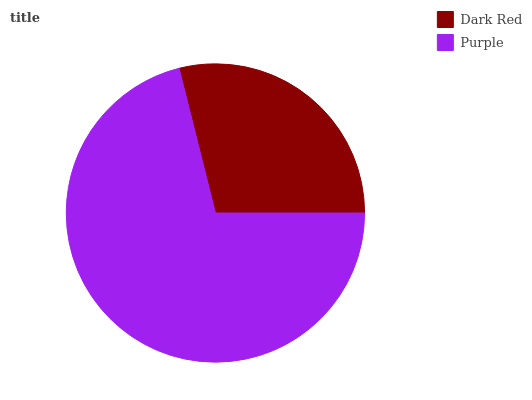Is Dark Red the minimum?
Answer yes or no. Yes. Is Purple the maximum?
Answer yes or no. Yes. Is Purple the minimum?
Answer yes or no. No. Is Purple greater than Dark Red?
Answer yes or no. Yes. Is Dark Red less than Purple?
Answer yes or no. Yes. Is Dark Red greater than Purple?
Answer yes or no. No. Is Purple less than Dark Red?
Answer yes or no. No. Is Purple the high median?
Answer yes or no. Yes. Is Dark Red the low median?
Answer yes or no. Yes. Is Dark Red the high median?
Answer yes or no. No. Is Purple the low median?
Answer yes or no. No. 